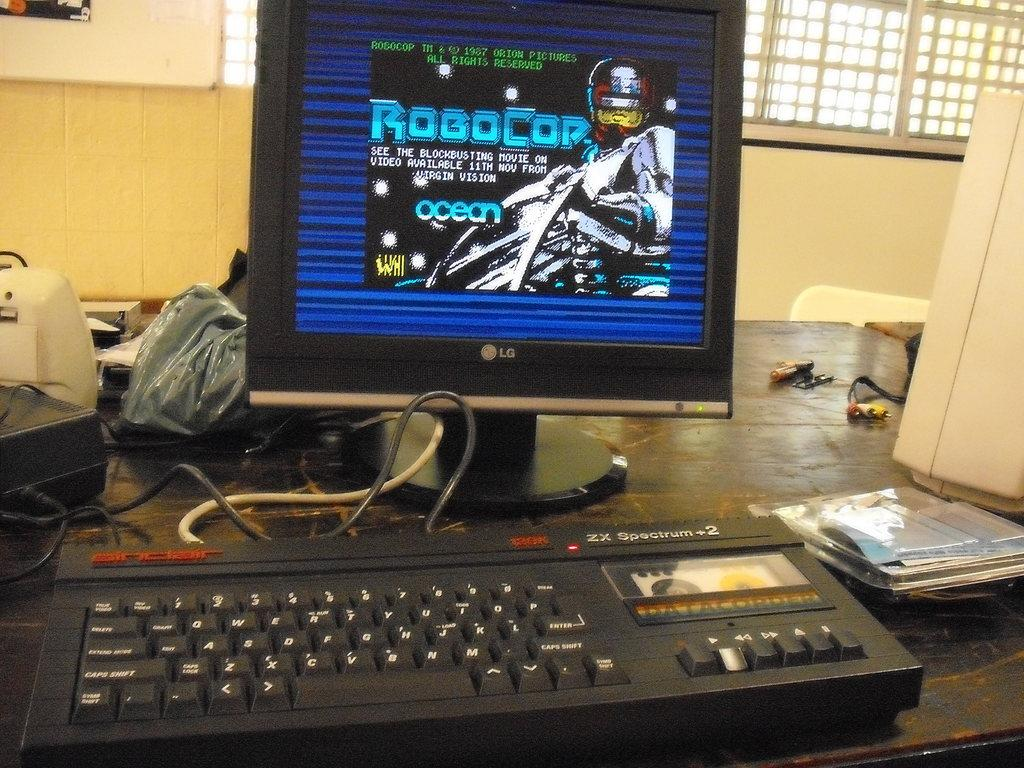Provide a one-sentence caption for the provided image. An old PC with an LG monitor dispalying RoboCop. 